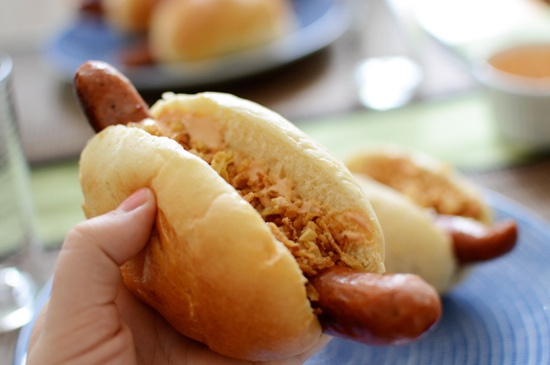Describe the objects in this image and their specific colors. I can see hot dog in darkgray, brown, tan, and maroon tones, people in darkgray, gray, maroon, tan, and brown tones, hot dog in darkgray, tan, and lightgray tones, bowl in darkgray, tan, and gray tones, and cup in darkgray, beige, and gray tones in this image. 